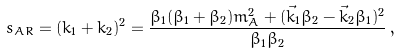<formula> <loc_0><loc_0><loc_500><loc_500>s _ { A R } = ( k _ { 1 } + k _ { 2 } ) ^ { 2 } = \frac { \beta _ { 1 } ( \beta _ { 1 } + \beta _ { 2 } ) m _ { A } ^ { 2 } + ( \vec { k } _ { 1 } \beta _ { 2 } - \vec { k } _ { 2 } \beta _ { 1 } ) ^ { 2 } } { \beta _ { 1 } \beta _ { 2 } } \, ,</formula> 